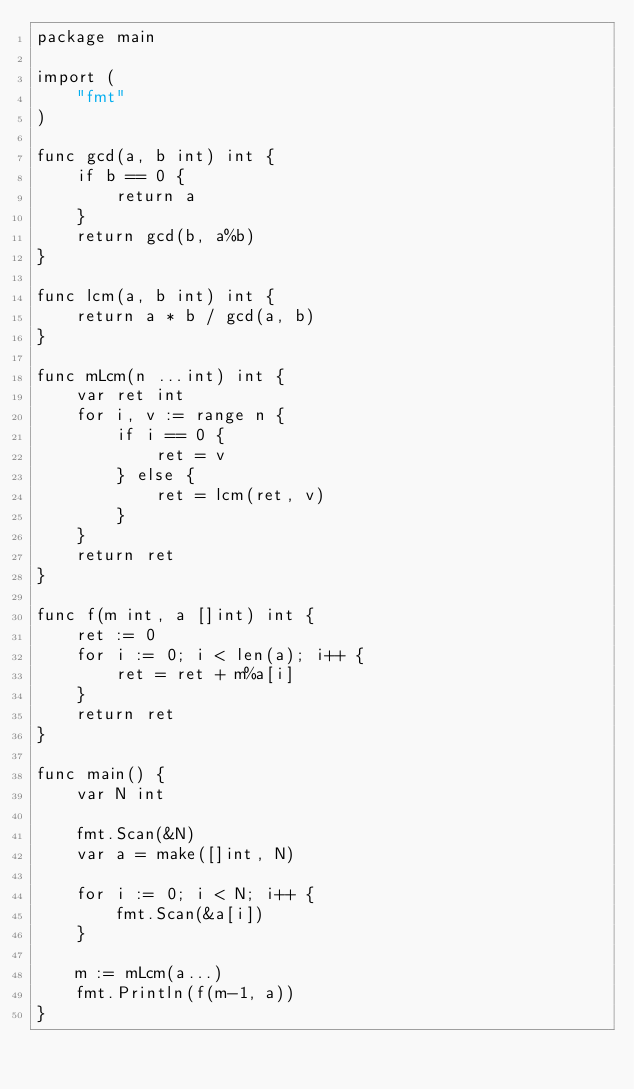<code> <loc_0><loc_0><loc_500><loc_500><_Go_>package main

import (
	"fmt"
)

func gcd(a, b int) int {
	if b == 0 {
		return a
	}
	return gcd(b, a%b)
}

func lcm(a, b int) int {
	return a * b / gcd(a, b)
}

func mLcm(n ...int) int {
	var ret int
	for i, v := range n {
		if i == 0 {
			ret = v
		} else {
			ret = lcm(ret, v)
		}
	}
	return ret
}

func f(m int, a []int) int {
	ret := 0
	for i := 0; i < len(a); i++ {
		ret = ret + m%a[i]
	}
	return ret
}

func main() {
	var N int

	fmt.Scan(&N)
	var a = make([]int, N)

	for i := 0; i < N; i++ {
		fmt.Scan(&a[i])
	}

	m := mLcm(a...)
	fmt.Println(f(m-1, a))
}
</code> 